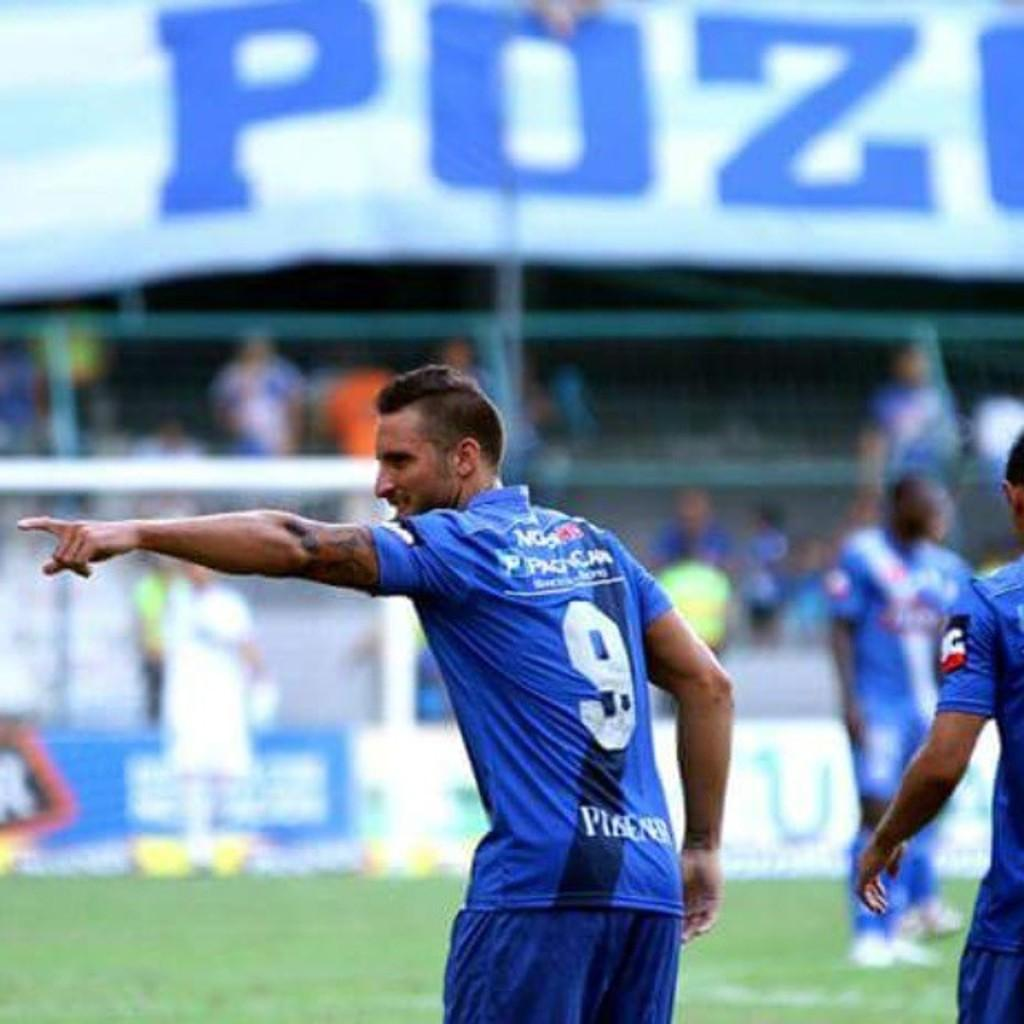<image>
Present a compact description of the photo's key features. a man in a blue jersey, number 9, is pointing to the crowd 